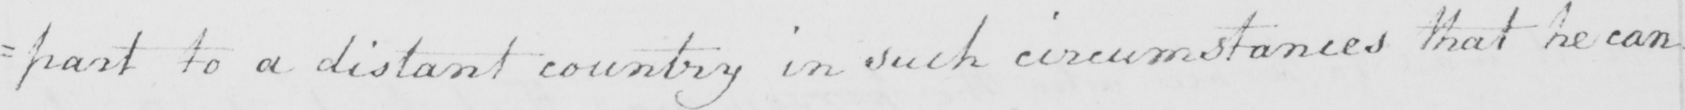What text is written in this handwritten line? : part to a distant country in such circumstances that he can : 